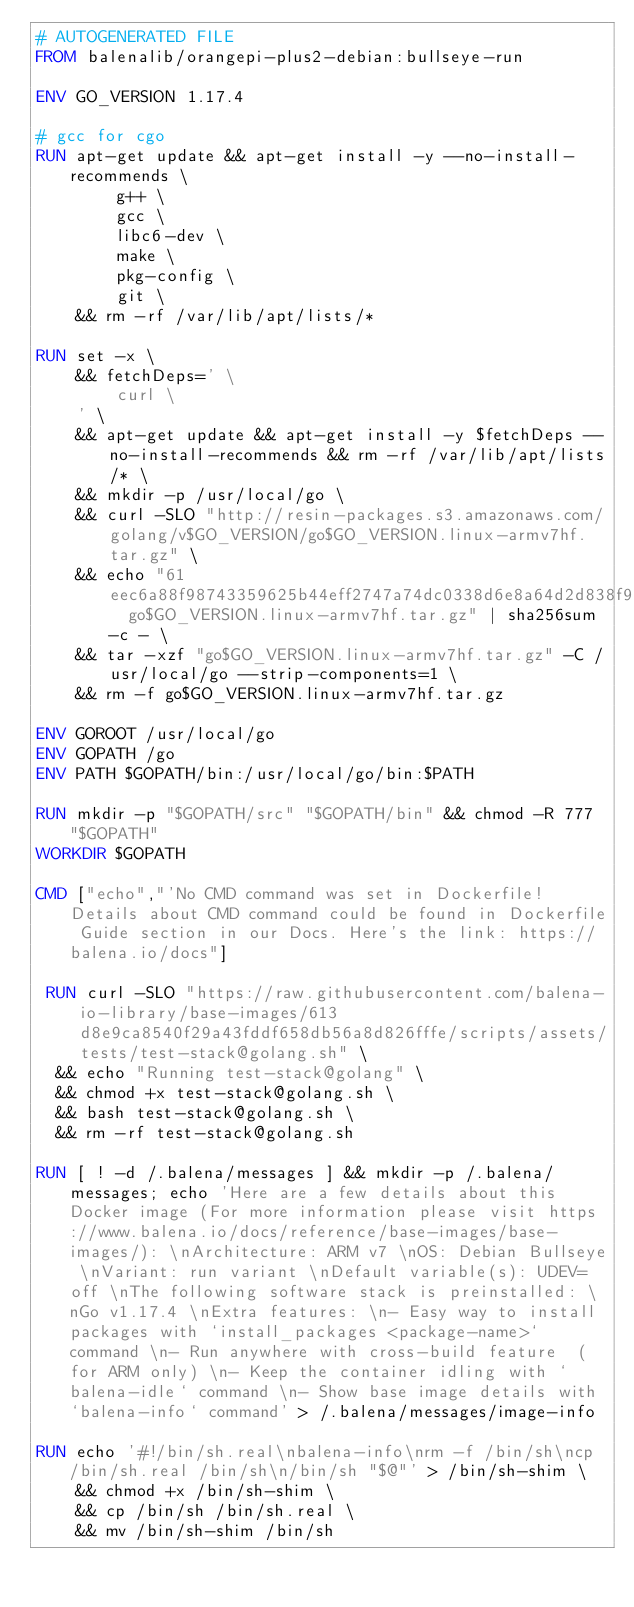Convert code to text. <code><loc_0><loc_0><loc_500><loc_500><_Dockerfile_># AUTOGENERATED FILE
FROM balenalib/orangepi-plus2-debian:bullseye-run

ENV GO_VERSION 1.17.4

# gcc for cgo
RUN apt-get update && apt-get install -y --no-install-recommends \
		g++ \
		gcc \
		libc6-dev \
		make \
		pkg-config \
		git \
	&& rm -rf /var/lib/apt/lists/*

RUN set -x \
	&& fetchDeps=' \
		curl \
	' \
	&& apt-get update && apt-get install -y $fetchDeps --no-install-recommends && rm -rf /var/lib/apt/lists/* \
	&& mkdir -p /usr/local/go \
	&& curl -SLO "http://resin-packages.s3.amazonaws.com/golang/v$GO_VERSION/go$GO_VERSION.linux-armv7hf.tar.gz" \
	&& echo "61eec6a88f98743359625b44eff2747a74dc0338d6e8a64d2d838f95dbd7050d  go$GO_VERSION.linux-armv7hf.tar.gz" | sha256sum -c - \
	&& tar -xzf "go$GO_VERSION.linux-armv7hf.tar.gz" -C /usr/local/go --strip-components=1 \
	&& rm -f go$GO_VERSION.linux-armv7hf.tar.gz

ENV GOROOT /usr/local/go
ENV GOPATH /go
ENV PATH $GOPATH/bin:/usr/local/go/bin:$PATH

RUN mkdir -p "$GOPATH/src" "$GOPATH/bin" && chmod -R 777 "$GOPATH"
WORKDIR $GOPATH

CMD ["echo","'No CMD command was set in Dockerfile! Details about CMD command could be found in Dockerfile Guide section in our Docs. Here's the link: https://balena.io/docs"]

 RUN curl -SLO "https://raw.githubusercontent.com/balena-io-library/base-images/613d8e9ca8540f29a43fddf658db56a8d826fffe/scripts/assets/tests/test-stack@golang.sh" \
  && echo "Running test-stack@golang" \
  && chmod +x test-stack@golang.sh \
  && bash test-stack@golang.sh \
  && rm -rf test-stack@golang.sh 

RUN [ ! -d /.balena/messages ] && mkdir -p /.balena/messages; echo 'Here are a few details about this Docker image (For more information please visit https://www.balena.io/docs/reference/base-images/base-images/): \nArchitecture: ARM v7 \nOS: Debian Bullseye \nVariant: run variant \nDefault variable(s): UDEV=off \nThe following software stack is preinstalled: \nGo v1.17.4 \nExtra features: \n- Easy way to install packages with `install_packages <package-name>` command \n- Run anywhere with cross-build feature  (for ARM only) \n- Keep the container idling with `balena-idle` command \n- Show base image details with `balena-info` command' > /.balena/messages/image-info

RUN echo '#!/bin/sh.real\nbalena-info\nrm -f /bin/sh\ncp /bin/sh.real /bin/sh\n/bin/sh "$@"' > /bin/sh-shim \
	&& chmod +x /bin/sh-shim \
	&& cp /bin/sh /bin/sh.real \
	&& mv /bin/sh-shim /bin/sh</code> 